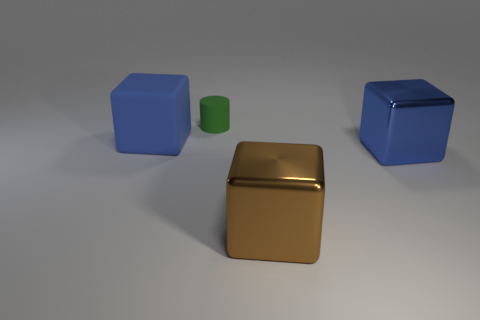Subtract all large blue matte cubes. How many cubes are left? 2 Subtract all brown spheres. How many blue blocks are left? 2 Add 4 big brown metallic objects. How many objects exist? 8 Subtract all blocks. How many objects are left? 1 Subtract all small blue rubber balls. Subtract all big blue things. How many objects are left? 2 Add 1 big metal things. How many big metal things are left? 3 Add 4 big blue rubber things. How many big blue rubber things exist? 5 Subtract 1 brown blocks. How many objects are left? 3 